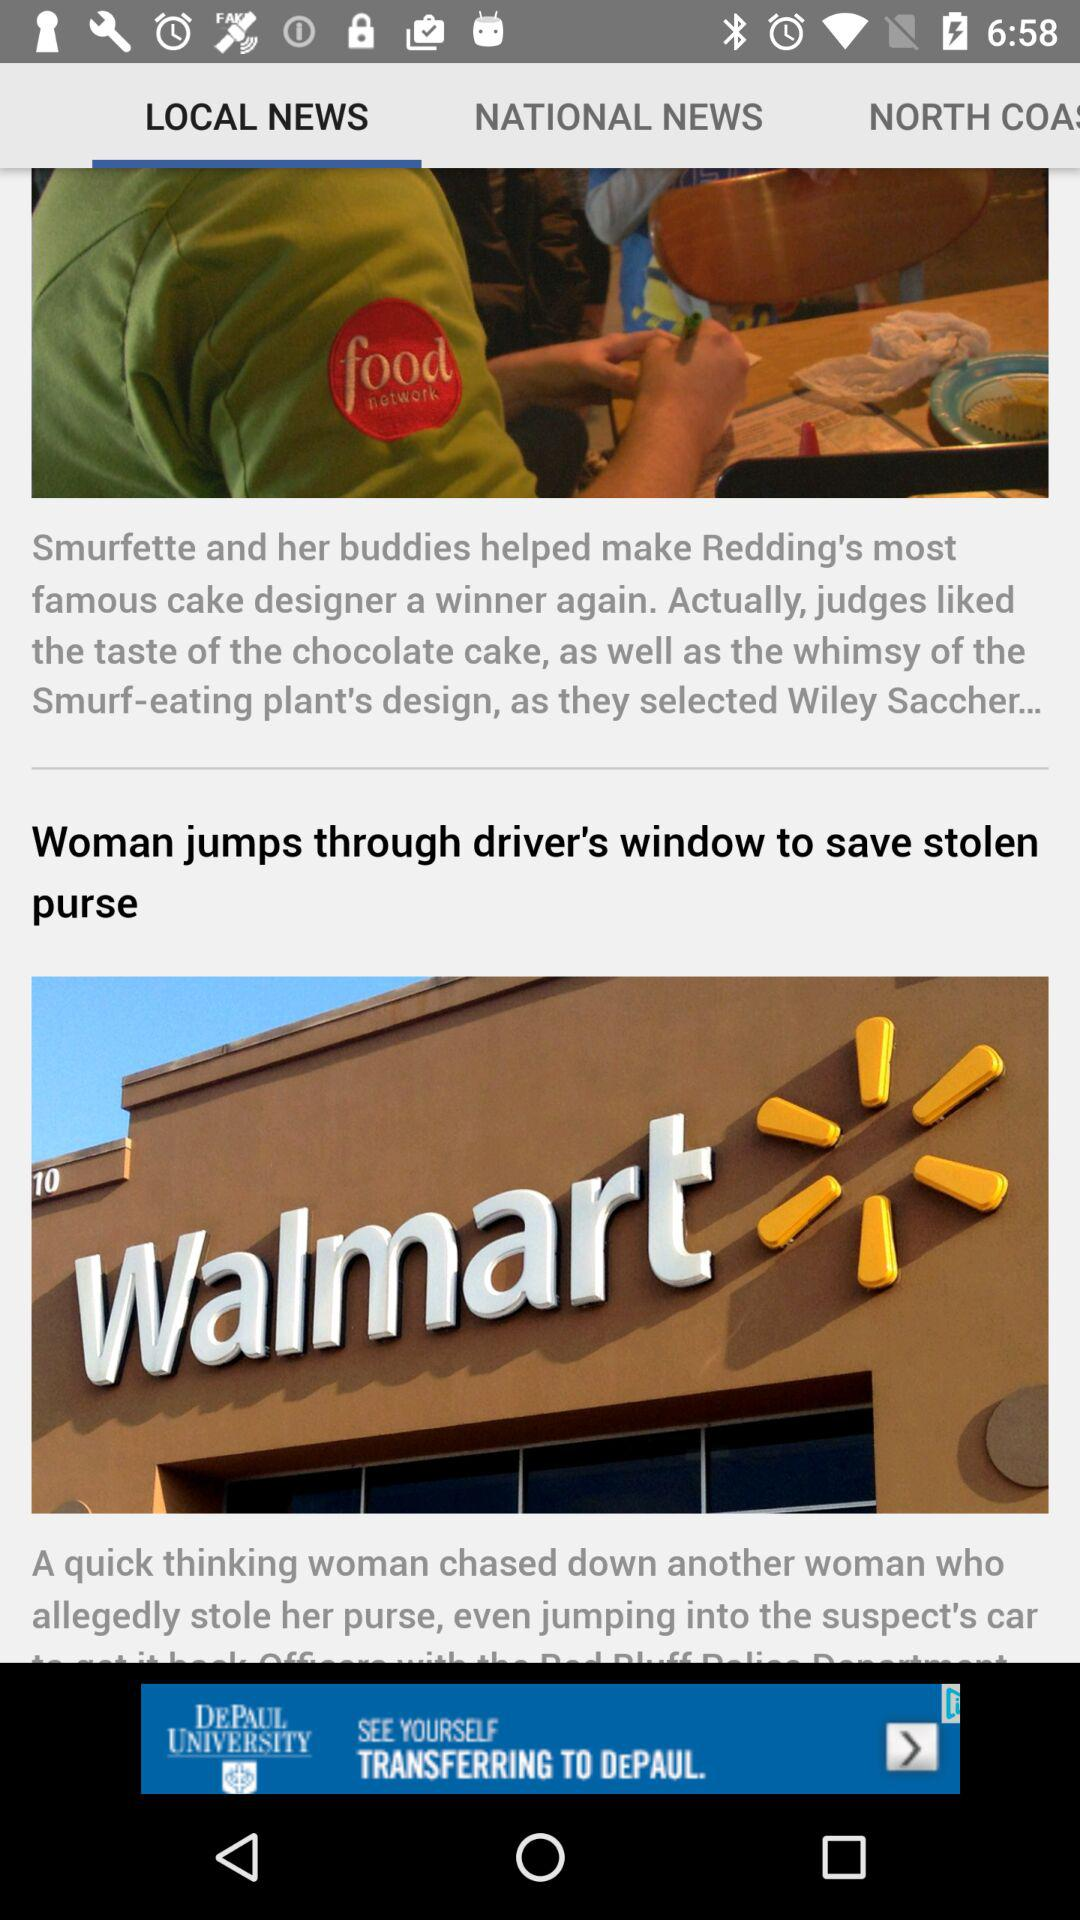Which tab is selected? The selected tab is "LOCAL NEWS". 